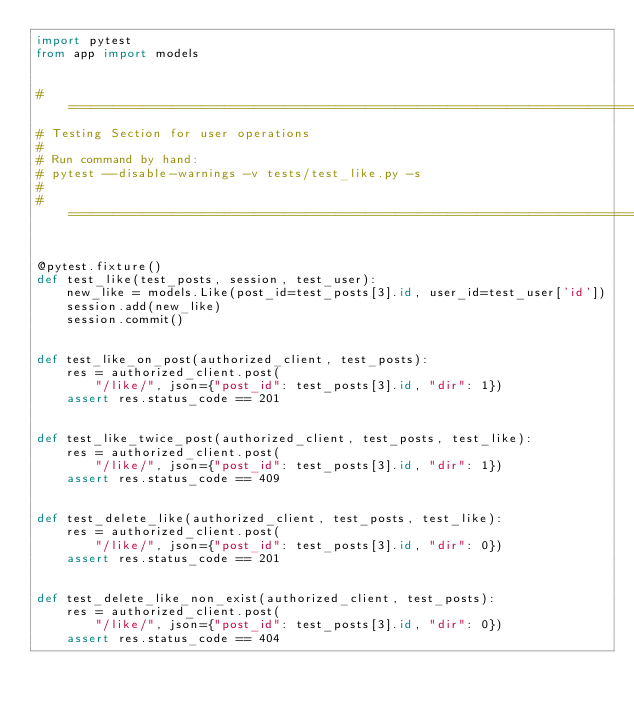Convert code to text. <code><loc_0><loc_0><loc_500><loc_500><_Python_>import pytest
from app import models


#===============================================================================
# Testing Section for user operations
#
# Run command by hand:
# pytest --disable-warnings -v tests/test_like.py -s
# 
#===============================================================================


@pytest.fixture()
def test_like(test_posts, session, test_user):
    new_like = models.Like(post_id=test_posts[3].id, user_id=test_user['id'])
    session.add(new_like)
    session.commit()


def test_like_on_post(authorized_client, test_posts):
    res = authorized_client.post(
        "/like/", json={"post_id": test_posts[3].id, "dir": 1})
    assert res.status_code == 201


def test_like_twice_post(authorized_client, test_posts, test_like):
    res = authorized_client.post(
        "/like/", json={"post_id": test_posts[3].id, "dir": 1})
    assert res.status_code == 409


def test_delete_like(authorized_client, test_posts, test_like):
    res = authorized_client.post(
        "/like/", json={"post_id": test_posts[3].id, "dir": 0})
    assert res.status_code == 201


def test_delete_like_non_exist(authorized_client, test_posts):
    res = authorized_client.post(
        "/like/", json={"post_id": test_posts[3].id, "dir": 0})
    assert res.status_code == 404

</code> 